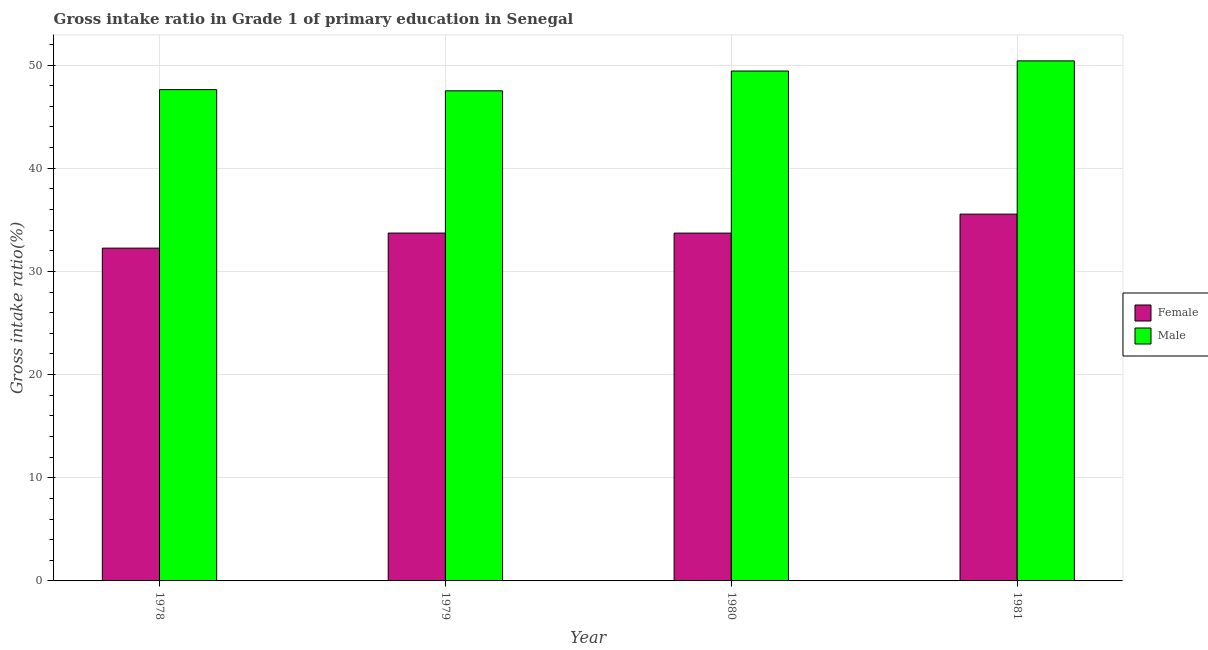How many different coloured bars are there?
Keep it short and to the point. 2. How many groups of bars are there?
Give a very brief answer. 4. Are the number of bars per tick equal to the number of legend labels?
Provide a short and direct response. Yes. Are the number of bars on each tick of the X-axis equal?
Keep it short and to the point. Yes. How many bars are there on the 2nd tick from the left?
Your answer should be compact. 2. How many bars are there on the 2nd tick from the right?
Make the answer very short. 2. What is the label of the 4th group of bars from the left?
Provide a short and direct response. 1981. What is the gross intake ratio(male) in 1978?
Offer a terse response. 47.62. Across all years, what is the maximum gross intake ratio(female)?
Offer a terse response. 35.55. Across all years, what is the minimum gross intake ratio(male)?
Your answer should be compact. 47.5. In which year was the gross intake ratio(male) minimum?
Keep it short and to the point. 1979. What is the total gross intake ratio(male) in the graph?
Offer a terse response. 194.95. What is the difference between the gross intake ratio(female) in 1979 and that in 1981?
Give a very brief answer. -1.83. What is the difference between the gross intake ratio(male) in 1978 and the gross intake ratio(female) in 1980?
Provide a succinct answer. -1.8. What is the average gross intake ratio(female) per year?
Ensure brevity in your answer.  33.81. In the year 1978, what is the difference between the gross intake ratio(female) and gross intake ratio(male)?
Your answer should be very brief. 0. In how many years, is the gross intake ratio(male) greater than 46 %?
Your answer should be compact. 4. What is the ratio of the gross intake ratio(male) in 1978 to that in 1981?
Provide a succinct answer. 0.94. Is the gross intake ratio(male) in 1979 less than that in 1981?
Make the answer very short. Yes. Is the difference between the gross intake ratio(female) in 1979 and 1981 greater than the difference between the gross intake ratio(male) in 1979 and 1981?
Your answer should be compact. No. What is the difference between the highest and the second highest gross intake ratio(male)?
Keep it short and to the point. 0.98. What is the difference between the highest and the lowest gross intake ratio(male)?
Give a very brief answer. 2.9. What does the 1st bar from the left in 1979 represents?
Your answer should be very brief. Female. Are all the bars in the graph horizontal?
Make the answer very short. No. How many years are there in the graph?
Ensure brevity in your answer.  4. Where does the legend appear in the graph?
Your answer should be very brief. Center right. How are the legend labels stacked?
Make the answer very short. Vertical. What is the title of the graph?
Offer a terse response. Gross intake ratio in Grade 1 of primary education in Senegal. Does "Manufacturing industries and construction" appear as one of the legend labels in the graph?
Your answer should be very brief. No. What is the label or title of the X-axis?
Provide a short and direct response. Year. What is the label or title of the Y-axis?
Provide a short and direct response. Gross intake ratio(%). What is the Gross intake ratio(%) of Female in 1978?
Keep it short and to the point. 32.26. What is the Gross intake ratio(%) of Male in 1978?
Your response must be concise. 47.62. What is the Gross intake ratio(%) in Female in 1979?
Make the answer very short. 33.72. What is the Gross intake ratio(%) of Male in 1979?
Offer a very short reply. 47.5. What is the Gross intake ratio(%) in Female in 1980?
Offer a terse response. 33.71. What is the Gross intake ratio(%) of Male in 1980?
Provide a succinct answer. 49.42. What is the Gross intake ratio(%) of Female in 1981?
Give a very brief answer. 35.55. What is the Gross intake ratio(%) in Male in 1981?
Your answer should be compact. 50.41. Across all years, what is the maximum Gross intake ratio(%) of Female?
Keep it short and to the point. 35.55. Across all years, what is the maximum Gross intake ratio(%) in Male?
Offer a very short reply. 50.41. Across all years, what is the minimum Gross intake ratio(%) in Female?
Your response must be concise. 32.26. Across all years, what is the minimum Gross intake ratio(%) of Male?
Your answer should be very brief. 47.5. What is the total Gross intake ratio(%) in Female in the graph?
Make the answer very short. 135.24. What is the total Gross intake ratio(%) of Male in the graph?
Ensure brevity in your answer.  194.95. What is the difference between the Gross intake ratio(%) of Female in 1978 and that in 1979?
Keep it short and to the point. -1.46. What is the difference between the Gross intake ratio(%) in Male in 1978 and that in 1979?
Offer a very short reply. 0.12. What is the difference between the Gross intake ratio(%) in Female in 1978 and that in 1980?
Your answer should be compact. -1.46. What is the difference between the Gross intake ratio(%) in Male in 1978 and that in 1980?
Make the answer very short. -1.8. What is the difference between the Gross intake ratio(%) in Female in 1978 and that in 1981?
Make the answer very short. -3.3. What is the difference between the Gross intake ratio(%) of Male in 1978 and that in 1981?
Provide a succinct answer. -2.79. What is the difference between the Gross intake ratio(%) of Female in 1979 and that in 1980?
Your answer should be very brief. 0. What is the difference between the Gross intake ratio(%) in Male in 1979 and that in 1980?
Provide a short and direct response. -1.92. What is the difference between the Gross intake ratio(%) in Female in 1979 and that in 1981?
Offer a terse response. -1.83. What is the difference between the Gross intake ratio(%) of Male in 1979 and that in 1981?
Offer a very short reply. -2.9. What is the difference between the Gross intake ratio(%) in Female in 1980 and that in 1981?
Offer a very short reply. -1.84. What is the difference between the Gross intake ratio(%) of Male in 1980 and that in 1981?
Keep it short and to the point. -0.98. What is the difference between the Gross intake ratio(%) of Female in 1978 and the Gross intake ratio(%) of Male in 1979?
Provide a succinct answer. -15.25. What is the difference between the Gross intake ratio(%) in Female in 1978 and the Gross intake ratio(%) in Male in 1980?
Make the answer very short. -17.17. What is the difference between the Gross intake ratio(%) in Female in 1978 and the Gross intake ratio(%) in Male in 1981?
Make the answer very short. -18.15. What is the difference between the Gross intake ratio(%) in Female in 1979 and the Gross intake ratio(%) in Male in 1980?
Keep it short and to the point. -15.71. What is the difference between the Gross intake ratio(%) of Female in 1979 and the Gross intake ratio(%) of Male in 1981?
Your response must be concise. -16.69. What is the difference between the Gross intake ratio(%) in Female in 1980 and the Gross intake ratio(%) in Male in 1981?
Provide a short and direct response. -16.69. What is the average Gross intake ratio(%) of Female per year?
Ensure brevity in your answer.  33.81. What is the average Gross intake ratio(%) in Male per year?
Ensure brevity in your answer.  48.74. In the year 1978, what is the difference between the Gross intake ratio(%) in Female and Gross intake ratio(%) in Male?
Provide a short and direct response. -15.36. In the year 1979, what is the difference between the Gross intake ratio(%) of Female and Gross intake ratio(%) of Male?
Offer a very short reply. -13.79. In the year 1980, what is the difference between the Gross intake ratio(%) in Female and Gross intake ratio(%) in Male?
Your response must be concise. -15.71. In the year 1981, what is the difference between the Gross intake ratio(%) of Female and Gross intake ratio(%) of Male?
Your answer should be compact. -14.85. What is the ratio of the Gross intake ratio(%) in Female in 1978 to that in 1979?
Provide a succinct answer. 0.96. What is the ratio of the Gross intake ratio(%) in Male in 1978 to that in 1979?
Ensure brevity in your answer.  1. What is the ratio of the Gross intake ratio(%) of Female in 1978 to that in 1980?
Your answer should be compact. 0.96. What is the ratio of the Gross intake ratio(%) of Male in 1978 to that in 1980?
Provide a short and direct response. 0.96. What is the ratio of the Gross intake ratio(%) of Female in 1978 to that in 1981?
Offer a very short reply. 0.91. What is the ratio of the Gross intake ratio(%) of Male in 1978 to that in 1981?
Make the answer very short. 0.94. What is the ratio of the Gross intake ratio(%) in Female in 1979 to that in 1980?
Your answer should be very brief. 1. What is the ratio of the Gross intake ratio(%) in Male in 1979 to that in 1980?
Your answer should be compact. 0.96. What is the ratio of the Gross intake ratio(%) of Female in 1979 to that in 1981?
Ensure brevity in your answer.  0.95. What is the ratio of the Gross intake ratio(%) in Male in 1979 to that in 1981?
Offer a terse response. 0.94. What is the ratio of the Gross intake ratio(%) in Female in 1980 to that in 1981?
Your answer should be very brief. 0.95. What is the ratio of the Gross intake ratio(%) of Male in 1980 to that in 1981?
Give a very brief answer. 0.98. What is the difference between the highest and the second highest Gross intake ratio(%) in Female?
Your response must be concise. 1.83. What is the difference between the highest and the second highest Gross intake ratio(%) in Male?
Offer a terse response. 0.98. What is the difference between the highest and the lowest Gross intake ratio(%) of Female?
Provide a short and direct response. 3.3. What is the difference between the highest and the lowest Gross intake ratio(%) of Male?
Your answer should be very brief. 2.9. 